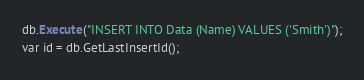<code> <loc_0><loc_0><loc_500><loc_500><_SQL_>db.Execute("INSERT INTO Data (Name) VALUES ('Smith')");
var id = db.GetLastInsertId();</code> 